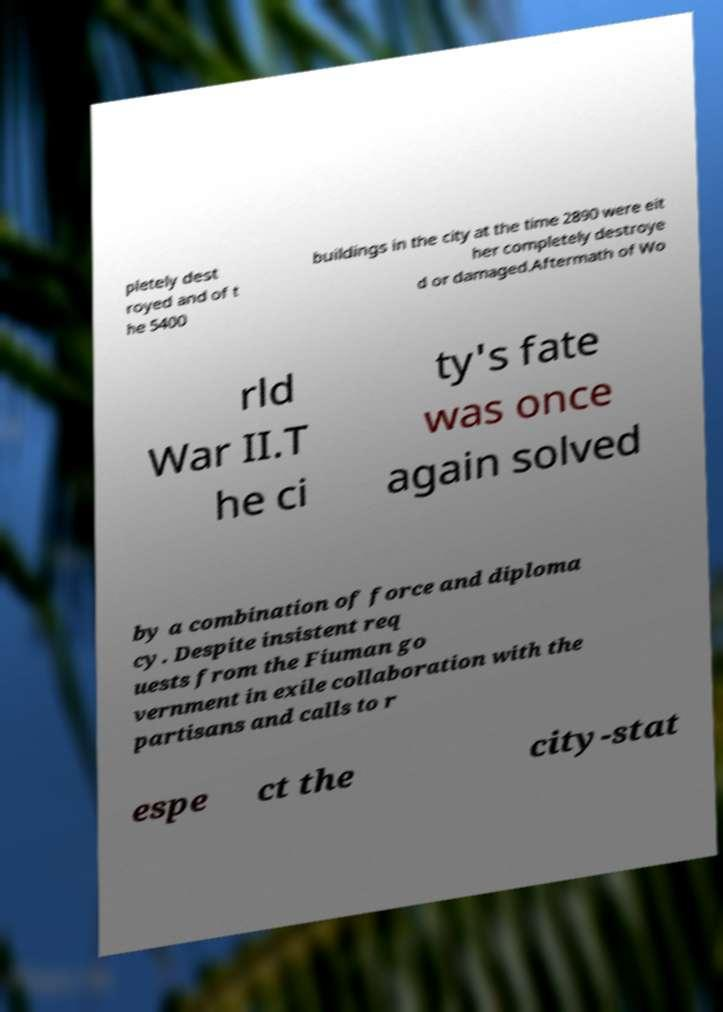What messages or text are displayed in this image? I need them in a readable, typed format. pletely dest royed and of t he 5400 buildings in the city at the time 2890 were eit her completely destroye d or damaged.Aftermath of Wo rld War II.T he ci ty's fate was once again solved by a combination of force and diploma cy. Despite insistent req uests from the Fiuman go vernment in exile collaboration with the partisans and calls to r espe ct the city-stat 